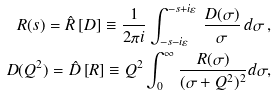<formula> <loc_0><loc_0><loc_500><loc_500>R ( s ) = \hat { R } \left [ D \right ] \equiv \frac { 1 } { 2 \pi i } \int _ { - s - i \varepsilon } ^ { - s + i \varepsilon } \, \frac { D ( \sigma ) } { \sigma } \, d \sigma \, , \\ D ( Q ^ { 2 } ) = \hat { D } \left [ R \right ] \equiv Q ^ { 2 } \int _ { 0 } ^ { \infty } \frac { R ( \sigma ) } { ( \sigma + Q ^ { 2 } ) ^ { 2 } } d \sigma ,</formula> 